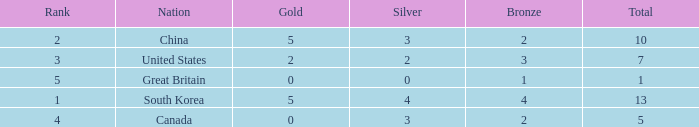What is Nation, when Rank is greater than 2, when Total is greater than 1, and when Bronze is less than 3? Canada. 